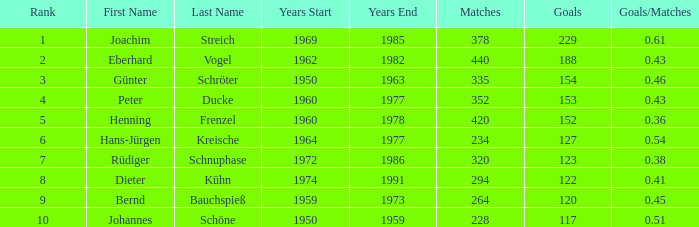43 involving joachim streich and more than 378 matches? None. 